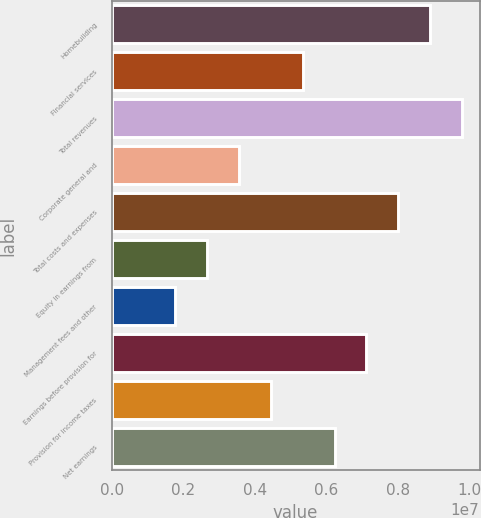Convert chart to OTSL. <chart><loc_0><loc_0><loc_500><loc_500><bar_chart><fcel>Homebuilding<fcel>Financial services<fcel>Total revenues<fcel>Corporate general and<fcel>Total costs and expenses<fcel>Equity in earnings from<fcel>Management fees and other<fcel>Earnings before provision for<fcel>Provision for income taxes<fcel>Net earnings<nl><fcel>8.90762e+06<fcel>5.34457e+06<fcel>9.79838e+06<fcel>3.56305e+06<fcel>8.01686e+06<fcel>2.67229e+06<fcel>1.78153e+06<fcel>7.1261e+06<fcel>4.45381e+06<fcel>6.23533e+06<nl></chart> 